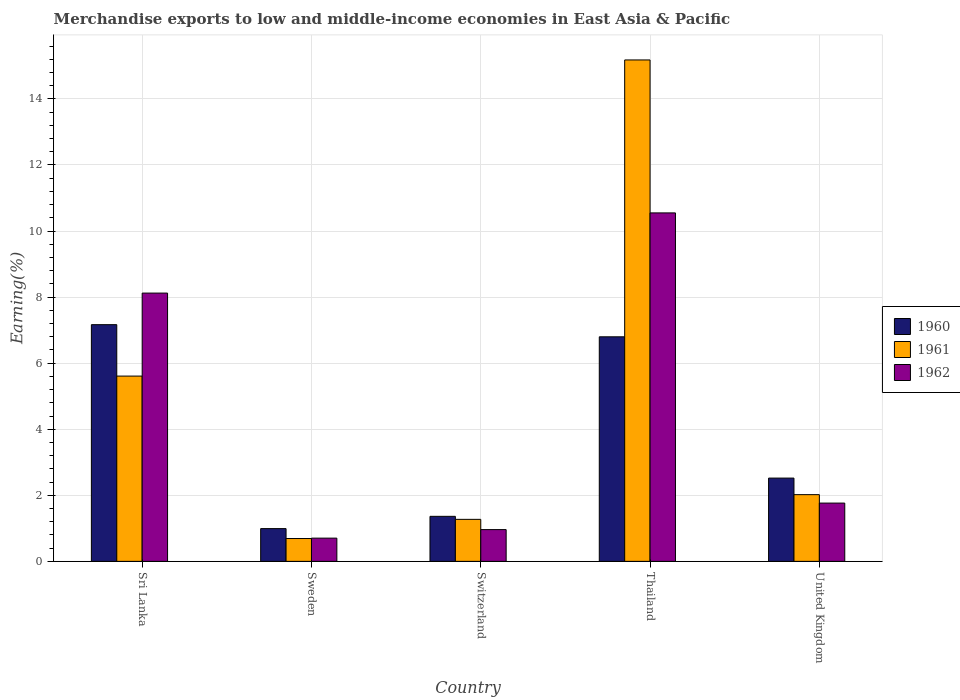Are the number of bars per tick equal to the number of legend labels?
Your response must be concise. Yes. Are the number of bars on each tick of the X-axis equal?
Provide a short and direct response. Yes. How many bars are there on the 4th tick from the left?
Offer a very short reply. 3. How many bars are there on the 4th tick from the right?
Make the answer very short. 3. What is the label of the 3rd group of bars from the left?
Your response must be concise. Switzerland. In how many cases, is the number of bars for a given country not equal to the number of legend labels?
Make the answer very short. 0. What is the percentage of amount earned from merchandise exports in 1962 in United Kingdom?
Keep it short and to the point. 1.76. Across all countries, what is the maximum percentage of amount earned from merchandise exports in 1962?
Make the answer very short. 10.55. Across all countries, what is the minimum percentage of amount earned from merchandise exports in 1962?
Make the answer very short. 0.7. In which country was the percentage of amount earned from merchandise exports in 1962 maximum?
Provide a succinct answer. Thailand. What is the total percentage of amount earned from merchandise exports in 1961 in the graph?
Your response must be concise. 24.77. What is the difference between the percentage of amount earned from merchandise exports in 1961 in Switzerland and that in Thailand?
Keep it short and to the point. -13.91. What is the difference between the percentage of amount earned from merchandise exports in 1960 in Switzerland and the percentage of amount earned from merchandise exports in 1962 in Sri Lanka?
Offer a terse response. -6.76. What is the average percentage of amount earned from merchandise exports in 1962 per country?
Ensure brevity in your answer.  4.42. What is the difference between the percentage of amount earned from merchandise exports of/in 1962 and percentage of amount earned from merchandise exports of/in 1960 in Thailand?
Ensure brevity in your answer.  3.75. What is the ratio of the percentage of amount earned from merchandise exports in 1962 in Switzerland to that in Thailand?
Your answer should be very brief. 0.09. Is the difference between the percentage of amount earned from merchandise exports in 1962 in Sweden and Thailand greater than the difference between the percentage of amount earned from merchandise exports in 1960 in Sweden and Thailand?
Provide a succinct answer. No. What is the difference between the highest and the second highest percentage of amount earned from merchandise exports in 1961?
Provide a short and direct response. -3.59. What is the difference between the highest and the lowest percentage of amount earned from merchandise exports in 1960?
Offer a terse response. 6.17. In how many countries, is the percentage of amount earned from merchandise exports in 1962 greater than the average percentage of amount earned from merchandise exports in 1962 taken over all countries?
Your response must be concise. 2. What does the 1st bar from the right in Switzerland represents?
Provide a short and direct response. 1962. Is it the case that in every country, the sum of the percentage of amount earned from merchandise exports in 1960 and percentage of amount earned from merchandise exports in 1962 is greater than the percentage of amount earned from merchandise exports in 1961?
Make the answer very short. Yes. How many bars are there?
Give a very brief answer. 15. How many countries are there in the graph?
Offer a terse response. 5. What is the difference between two consecutive major ticks on the Y-axis?
Offer a terse response. 2. Does the graph contain grids?
Offer a terse response. Yes. How are the legend labels stacked?
Offer a terse response. Vertical. What is the title of the graph?
Your answer should be compact. Merchandise exports to low and middle-income economies in East Asia & Pacific. What is the label or title of the X-axis?
Keep it short and to the point. Country. What is the label or title of the Y-axis?
Your response must be concise. Earning(%). What is the Earning(%) in 1960 in Sri Lanka?
Keep it short and to the point. 7.17. What is the Earning(%) in 1961 in Sri Lanka?
Your response must be concise. 5.61. What is the Earning(%) in 1962 in Sri Lanka?
Keep it short and to the point. 8.12. What is the Earning(%) of 1960 in Sweden?
Make the answer very short. 0.99. What is the Earning(%) of 1961 in Sweden?
Your response must be concise. 0.69. What is the Earning(%) in 1962 in Sweden?
Offer a very short reply. 0.7. What is the Earning(%) in 1960 in Switzerland?
Provide a succinct answer. 1.36. What is the Earning(%) of 1961 in Switzerland?
Make the answer very short. 1.27. What is the Earning(%) of 1962 in Switzerland?
Your response must be concise. 0.96. What is the Earning(%) of 1960 in Thailand?
Ensure brevity in your answer.  6.8. What is the Earning(%) in 1961 in Thailand?
Provide a succinct answer. 15.18. What is the Earning(%) in 1962 in Thailand?
Offer a terse response. 10.55. What is the Earning(%) in 1960 in United Kingdom?
Ensure brevity in your answer.  2.52. What is the Earning(%) of 1961 in United Kingdom?
Offer a very short reply. 2.02. What is the Earning(%) in 1962 in United Kingdom?
Your response must be concise. 1.76. Across all countries, what is the maximum Earning(%) of 1960?
Offer a very short reply. 7.17. Across all countries, what is the maximum Earning(%) in 1961?
Ensure brevity in your answer.  15.18. Across all countries, what is the maximum Earning(%) of 1962?
Make the answer very short. 10.55. Across all countries, what is the minimum Earning(%) of 1960?
Offer a terse response. 0.99. Across all countries, what is the minimum Earning(%) in 1961?
Offer a terse response. 0.69. Across all countries, what is the minimum Earning(%) of 1962?
Your answer should be very brief. 0.7. What is the total Earning(%) of 1960 in the graph?
Offer a very short reply. 18.84. What is the total Earning(%) of 1961 in the graph?
Provide a short and direct response. 24.77. What is the total Earning(%) of 1962 in the graph?
Offer a terse response. 22.1. What is the difference between the Earning(%) of 1960 in Sri Lanka and that in Sweden?
Give a very brief answer. 6.17. What is the difference between the Earning(%) in 1961 in Sri Lanka and that in Sweden?
Your response must be concise. 4.92. What is the difference between the Earning(%) in 1962 in Sri Lanka and that in Sweden?
Provide a succinct answer. 7.42. What is the difference between the Earning(%) of 1960 in Sri Lanka and that in Switzerland?
Ensure brevity in your answer.  5.8. What is the difference between the Earning(%) in 1961 in Sri Lanka and that in Switzerland?
Give a very brief answer. 4.34. What is the difference between the Earning(%) of 1962 in Sri Lanka and that in Switzerland?
Your response must be concise. 7.16. What is the difference between the Earning(%) of 1960 in Sri Lanka and that in Thailand?
Your answer should be compact. 0.37. What is the difference between the Earning(%) of 1961 in Sri Lanka and that in Thailand?
Offer a terse response. -9.57. What is the difference between the Earning(%) of 1962 in Sri Lanka and that in Thailand?
Provide a short and direct response. -2.43. What is the difference between the Earning(%) of 1960 in Sri Lanka and that in United Kingdom?
Ensure brevity in your answer.  4.64. What is the difference between the Earning(%) in 1961 in Sri Lanka and that in United Kingdom?
Your answer should be compact. 3.59. What is the difference between the Earning(%) of 1962 in Sri Lanka and that in United Kingdom?
Offer a terse response. 6.36. What is the difference between the Earning(%) of 1960 in Sweden and that in Switzerland?
Ensure brevity in your answer.  -0.37. What is the difference between the Earning(%) in 1961 in Sweden and that in Switzerland?
Give a very brief answer. -0.58. What is the difference between the Earning(%) in 1962 in Sweden and that in Switzerland?
Your answer should be compact. -0.26. What is the difference between the Earning(%) in 1960 in Sweden and that in Thailand?
Give a very brief answer. -5.81. What is the difference between the Earning(%) of 1961 in Sweden and that in Thailand?
Your response must be concise. -14.49. What is the difference between the Earning(%) of 1962 in Sweden and that in Thailand?
Your answer should be compact. -9.85. What is the difference between the Earning(%) of 1960 in Sweden and that in United Kingdom?
Provide a short and direct response. -1.53. What is the difference between the Earning(%) of 1961 in Sweden and that in United Kingdom?
Offer a very short reply. -1.33. What is the difference between the Earning(%) of 1962 in Sweden and that in United Kingdom?
Provide a short and direct response. -1.06. What is the difference between the Earning(%) in 1960 in Switzerland and that in Thailand?
Your response must be concise. -5.44. What is the difference between the Earning(%) of 1961 in Switzerland and that in Thailand?
Provide a short and direct response. -13.91. What is the difference between the Earning(%) of 1962 in Switzerland and that in Thailand?
Offer a terse response. -9.59. What is the difference between the Earning(%) of 1960 in Switzerland and that in United Kingdom?
Give a very brief answer. -1.16. What is the difference between the Earning(%) in 1961 in Switzerland and that in United Kingdom?
Make the answer very short. -0.75. What is the difference between the Earning(%) in 1962 in Switzerland and that in United Kingdom?
Give a very brief answer. -0.8. What is the difference between the Earning(%) of 1960 in Thailand and that in United Kingdom?
Provide a succinct answer. 4.28. What is the difference between the Earning(%) in 1961 in Thailand and that in United Kingdom?
Offer a very short reply. 13.16. What is the difference between the Earning(%) in 1962 in Thailand and that in United Kingdom?
Your answer should be very brief. 8.79. What is the difference between the Earning(%) of 1960 in Sri Lanka and the Earning(%) of 1961 in Sweden?
Your answer should be very brief. 6.47. What is the difference between the Earning(%) of 1960 in Sri Lanka and the Earning(%) of 1962 in Sweden?
Your answer should be very brief. 6.46. What is the difference between the Earning(%) of 1961 in Sri Lanka and the Earning(%) of 1962 in Sweden?
Offer a very short reply. 4.91. What is the difference between the Earning(%) of 1960 in Sri Lanka and the Earning(%) of 1961 in Switzerland?
Make the answer very short. 5.89. What is the difference between the Earning(%) of 1960 in Sri Lanka and the Earning(%) of 1962 in Switzerland?
Make the answer very short. 6.2. What is the difference between the Earning(%) in 1961 in Sri Lanka and the Earning(%) in 1962 in Switzerland?
Make the answer very short. 4.65. What is the difference between the Earning(%) in 1960 in Sri Lanka and the Earning(%) in 1961 in Thailand?
Provide a succinct answer. -8.01. What is the difference between the Earning(%) of 1960 in Sri Lanka and the Earning(%) of 1962 in Thailand?
Offer a terse response. -3.38. What is the difference between the Earning(%) in 1961 in Sri Lanka and the Earning(%) in 1962 in Thailand?
Offer a very short reply. -4.94. What is the difference between the Earning(%) in 1960 in Sri Lanka and the Earning(%) in 1961 in United Kingdom?
Ensure brevity in your answer.  5.15. What is the difference between the Earning(%) in 1960 in Sri Lanka and the Earning(%) in 1962 in United Kingdom?
Provide a succinct answer. 5.4. What is the difference between the Earning(%) of 1961 in Sri Lanka and the Earning(%) of 1962 in United Kingdom?
Your response must be concise. 3.84. What is the difference between the Earning(%) in 1960 in Sweden and the Earning(%) in 1961 in Switzerland?
Make the answer very short. -0.28. What is the difference between the Earning(%) of 1960 in Sweden and the Earning(%) of 1962 in Switzerland?
Make the answer very short. 0.03. What is the difference between the Earning(%) in 1961 in Sweden and the Earning(%) in 1962 in Switzerland?
Ensure brevity in your answer.  -0.27. What is the difference between the Earning(%) in 1960 in Sweden and the Earning(%) in 1961 in Thailand?
Give a very brief answer. -14.19. What is the difference between the Earning(%) in 1960 in Sweden and the Earning(%) in 1962 in Thailand?
Your answer should be compact. -9.56. What is the difference between the Earning(%) in 1961 in Sweden and the Earning(%) in 1962 in Thailand?
Your response must be concise. -9.86. What is the difference between the Earning(%) of 1960 in Sweden and the Earning(%) of 1961 in United Kingdom?
Keep it short and to the point. -1.03. What is the difference between the Earning(%) of 1960 in Sweden and the Earning(%) of 1962 in United Kingdom?
Offer a terse response. -0.77. What is the difference between the Earning(%) of 1961 in Sweden and the Earning(%) of 1962 in United Kingdom?
Provide a succinct answer. -1.07. What is the difference between the Earning(%) in 1960 in Switzerland and the Earning(%) in 1961 in Thailand?
Offer a terse response. -13.82. What is the difference between the Earning(%) in 1960 in Switzerland and the Earning(%) in 1962 in Thailand?
Your answer should be very brief. -9.19. What is the difference between the Earning(%) of 1961 in Switzerland and the Earning(%) of 1962 in Thailand?
Make the answer very short. -9.28. What is the difference between the Earning(%) in 1960 in Switzerland and the Earning(%) in 1961 in United Kingdom?
Give a very brief answer. -0.66. What is the difference between the Earning(%) in 1960 in Switzerland and the Earning(%) in 1962 in United Kingdom?
Offer a very short reply. -0.4. What is the difference between the Earning(%) in 1961 in Switzerland and the Earning(%) in 1962 in United Kingdom?
Your answer should be very brief. -0.49. What is the difference between the Earning(%) of 1960 in Thailand and the Earning(%) of 1961 in United Kingdom?
Provide a short and direct response. 4.78. What is the difference between the Earning(%) of 1960 in Thailand and the Earning(%) of 1962 in United Kingdom?
Offer a terse response. 5.03. What is the difference between the Earning(%) of 1961 in Thailand and the Earning(%) of 1962 in United Kingdom?
Your answer should be compact. 13.42. What is the average Earning(%) of 1960 per country?
Offer a terse response. 3.77. What is the average Earning(%) in 1961 per country?
Give a very brief answer. 4.95. What is the average Earning(%) of 1962 per country?
Provide a succinct answer. 4.42. What is the difference between the Earning(%) of 1960 and Earning(%) of 1961 in Sri Lanka?
Give a very brief answer. 1.56. What is the difference between the Earning(%) of 1960 and Earning(%) of 1962 in Sri Lanka?
Give a very brief answer. -0.96. What is the difference between the Earning(%) of 1961 and Earning(%) of 1962 in Sri Lanka?
Provide a short and direct response. -2.51. What is the difference between the Earning(%) of 1960 and Earning(%) of 1961 in Sweden?
Your response must be concise. 0.3. What is the difference between the Earning(%) in 1960 and Earning(%) in 1962 in Sweden?
Provide a succinct answer. 0.29. What is the difference between the Earning(%) of 1961 and Earning(%) of 1962 in Sweden?
Provide a succinct answer. -0.01. What is the difference between the Earning(%) in 1960 and Earning(%) in 1961 in Switzerland?
Your answer should be compact. 0.09. What is the difference between the Earning(%) of 1960 and Earning(%) of 1962 in Switzerland?
Offer a very short reply. 0.4. What is the difference between the Earning(%) of 1961 and Earning(%) of 1962 in Switzerland?
Provide a short and direct response. 0.31. What is the difference between the Earning(%) in 1960 and Earning(%) in 1961 in Thailand?
Give a very brief answer. -8.38. What is the difference between the Earning(%) in 1960 and Earning(%) in 1962 in Thailand?
Your answer should be very brief. -3.75. What is the difference between the Earning(%) of 1961 and Earning(%) of 1962 in Thailand?
Provide a succinct answer. 4.63. What is the difference between the Earning(%) of 1960 and Earning(%) of 1961 in United Kingdom?
Your answer should be compact. 0.5. What is the difference between the Earning(%) of 1960 and Earning(%) of 1962 in United Kingdom?
Ensure brevity in your answer.  0.76. What is the difference between the Earning(%) in 1961 and Earning(%) in 1962 in United Kingdom?
Give a very brief answer. 0.26. What is the ratio of the Earning(%) of 1960 in Sri Lanka to that in Sweden?
Keep it short and to the point. 7.23. What is the ratio of the Earning(%) of 1961 in Sri Lanka to that in Sweden?
Your response must be concise. 8.11. What is the ratio of the Earning(%) in 1962 in Sri Lanka to that in Sweden?
Give a very brief answer. 11.55. What is the ratio of the Earning(%) of 1960 in Sri Lanka to that in Switzerland?
Make the answer very short. 5.26. What is the ratio of the Earning(%) of 1961 in Sri Lanka to that in Switzerland?
Make the answer very short. 4.41. What is the ratio of the Earning(%) of 1962 in Sri Lanka to that in Switzerland?
Your answer should be compact. 8.44. What is the ratio of the Earning(%) in 1960 in Sri Lanka to that in Thailand?
Your response must be concise. 1.05. What is the ratio of the Earning(%) of 1961 in Sri Lanka to that in Thailand?
Your answer should be compact. 0.37. What is the ratio of the Earning(%) of 1962 in Sri Lanka to that in Thailand?
Provide a short and direct response. 0.77. What is the ratio of the Earning(%) in 1960 in Sri Lanka to that in United Kingdom?
Your response must be concise. 2.84. What is the ratio of the Earning(%) in 1961 in Sri Lanka to that in United Kingdom?
Offer a very short reply. 2.78. What is the ratio of the Earning(%) of 1962 in Sri Lanka to that in United Kingdom?
Ensure brevity in your answer.  4.6. What is the ratio of the Earning(%) of 1960 in Sweden to that in Switzerland?
Offer a very short reply. 0.73. What is the ratio of the Earning(%) in 1961 in Sweden to that in Switzerland?
Offer a very short reply. 0.54. What is the ratio of the Earning(%) of 1962 in Sweden to that in Switzerland?
Give a very brief answer. 0.73. What is the ratio of the Earning(%) in 1960 in Sweden to that in Thailand?
Make the answer very short. 0.15. What is the ratio of the Earning(%) in 1961 in Sweden to that in Thailand?
Provide a succinct answer. 0.05. What is the ratio of the Earning(%) in 1962 in Sweden to that in Thailand?
Keep it short and to the point. 0.07. What is the ratio of the Earning(%) in 1960 in Sweden to that in United Kingdom?
Make the answer very short. 0.39. What is the ratio of the Earning(%) of 1961 in Sweden to that in United Kingdom?
Keep it short and to the point. 0.34. What is the ratio of the Earning(%) of 1962 in Sweden to that in United Kingdom?
Provide a succinct answer. 0.4. What is the ratio of the Earning(%) of 1960 in Switzerland to that in Thailand?
Offer a very short reply. 0.2. What is the ratio of the Earning(%) in 1961 in Switzerland to that in Thailand?
Make the answer very short. 0.08. What is the ratio of the Earning(%) in 1962 in Switzerland to that in Thailand?
Provide a short and direct response. 0.09. What is the ratio of the Earning(%) of 1960 in Switzerland to that in United Kingdom?
Provide a short and direct response. 0.54. What is the ratio of the Earning(%) in 1961 in Switzerland to that in United Kingdom?
Your answer should be very brief. 0.63. What is the ratio of the Earning(%) in 1962 in Switzerland to that in United Kingdom?
Your response must be concise. 0.55. What is the ratio of the Earning(%) of 1960 in Thailand to that in United Kingdom?
Your answer should be very brief. 2.7. What is the ratio of the Earning(%) in 1961 in Thailand to that in United Kingdom?
Provide a short and direct response. 7.52. What is the ratio of the Earning(%) of 1962 in Thailand to that in United Kingdom?
Offer a terse response. 5.98. What is the difference between the highest and the second highest Earning(%) in 1960?
Your response must be concise. 0.37. What is the difference between the highest and the second highest Earning(%) in 1961?
Provide a short and direct response. 9.57. What is the difference between the highest and the second highest Earning(%) in 1962?
Provide a short and direct response. 2.43. What is the difference between the highest and the lowest Earning(%) of 1960?
Your answer should be very brief. 6.17. What is the difference between the highest and the lowest Earning(%) in 1961?
Offer a very short reply. 14.49. What is the difference between the highest and the lowest Earning(%) in 1962?
Make the answer very short. 9.85. 